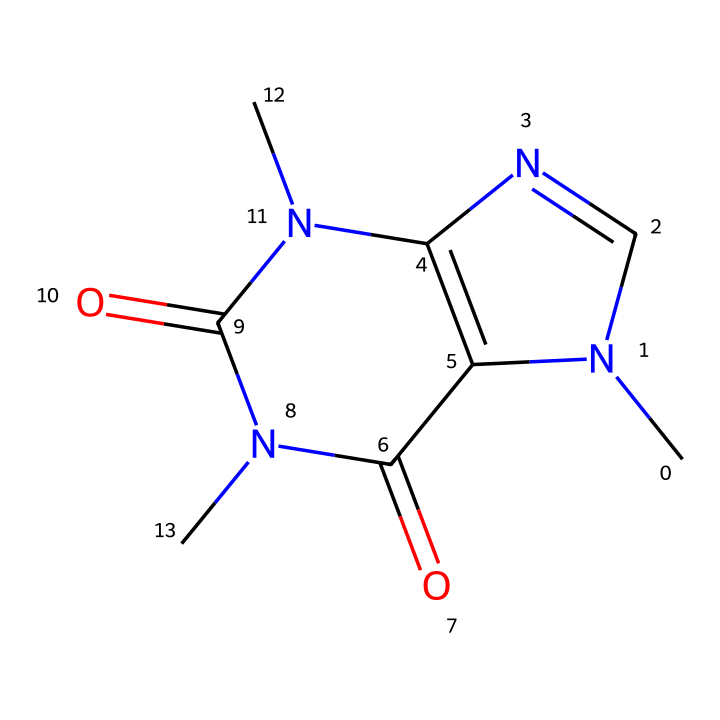What is the molecular formula of the caffeine? The SMILES string indicates the presence of various atoms: 8 carbon (C), 10 hydrogen (H), 4 nitrogen (N), and 2 oxygen (O). Thus, the molecular formula is C8H10N4O2.
Answer: C8H10N4O2 How many rings are present in the structure of caffeine? By examining the SMILES structure, we can identify two rings due to the 'N' and '=' signs indicating ring closures. These features clearly represent two interconnected cyclic components.
Answer: 2 What type of compound is caffeine classified as? The structure of caffeine shows multiple nitrogen atoms which categorize it under alkaloids, a class of naturally occurring organic compounds that mostly contain basic nitrogen atoms.
Answer: alkaloid Which atoms contribute to the basicity of caffeine? The nitrogen atoms in the structure are key in contributing to basicity because they can donate lone pairs of electrons, making caffeine a basic compound.
Answer: nitrogen How many double bonds are in the caffeine molecule? The SMILES representation contains '=' signs which denote double bonds. By counting these occurrences, we find there are four double bonds in the entire structure.
Answer: 4 What functional groups are present in caffeine? Analyzing the structure reveals the presence of amine and carbonyl functional groups. The nitrogen atoms indicate the amine nature, while the carbonyls are indicated by C=O links.
Answer: amine, carbonyl 